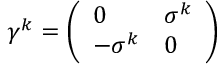<formula> <loc_0><loc_0><loc_500><loc_500>\gamma ^ { k } = { \left ( \begin{array} { l l } { 0 } & { \sigma ^ { k } } \\ { - \sigma ^ { k } } & { 0 } \end{array} \right ) }</formula> 